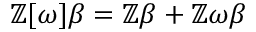<formula> <loc_0><loc_0><loc_500><loc_500>\mathbb { Z } [ \omega ] \beta = \mathbb { Z } \beta + \mathbb { Z } \omega \beta</formula> 